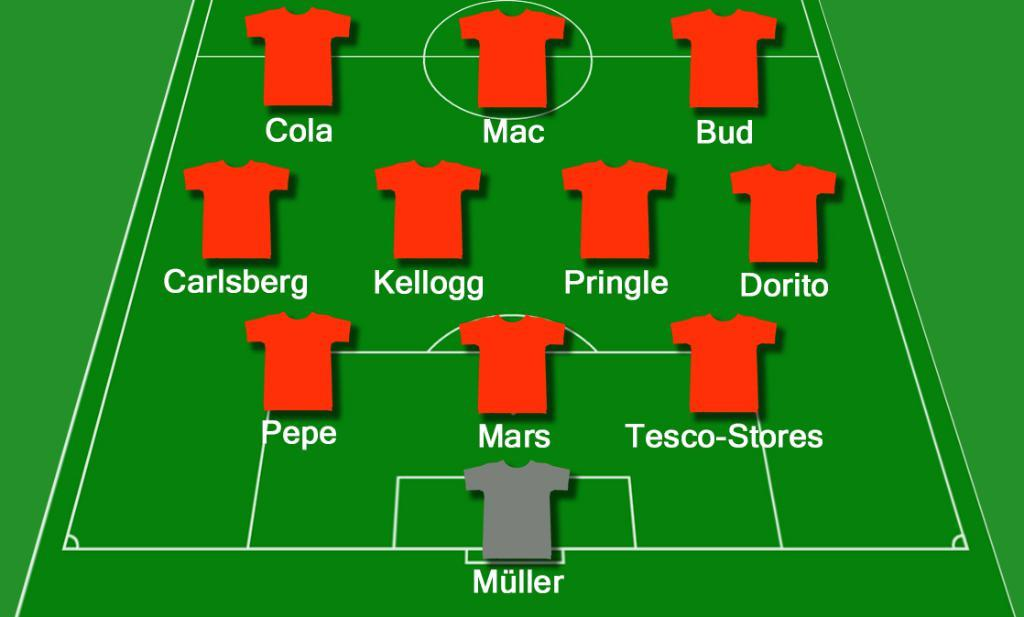Provide a one-sentence caption for the provided image. A grey shirt is designated as Muller in the goal. 